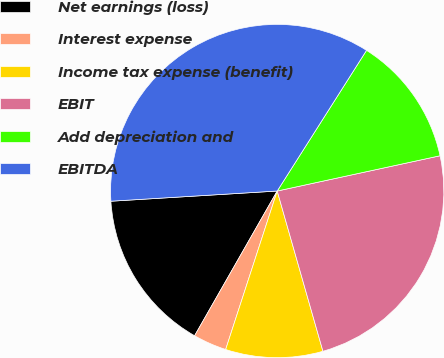Convert chart. <chart><loc_0><loc_0><loc_500><loc_500><pie_chart><fcel>Net earnings (loss)<fcel>Interest expense<fcel>Income tax expense (benefit)<fcel>EBIT<fcel>Add depreciation and<fcel>EBITDA<nl><fcel>15.77%<fcel>3.25%<fcel>9.43%<fcel>23.97%<fcel>12.6%<fcel>34.98%<nl></chart> 